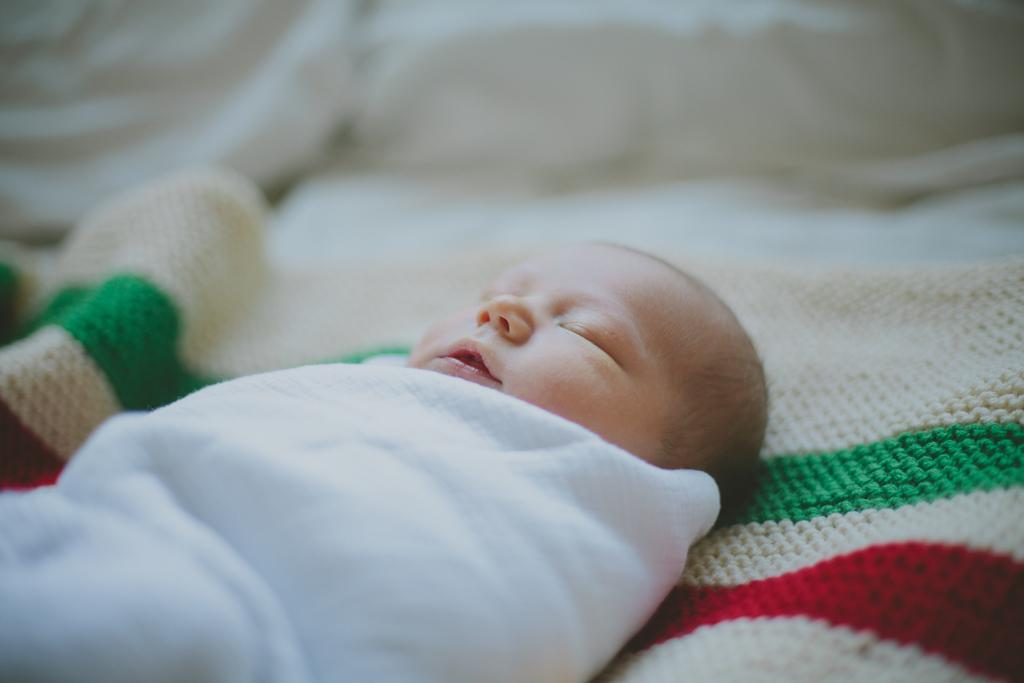What is the main subject of the image? There is a baby in the image. Where is the baby located? The baby is on a bed. What else can be seen in the image besides the baby? There are pillows in the image. What is covering the baby? There is a white cloth on the baby. What type of beast is depicted in the image? There is no beast present in the image; it features a baby on a bed with pillows and a white cloth. 